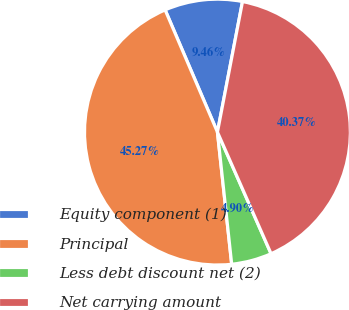Convert chart. <chart><loc_0><loc_0><loc_500><loc_500><pie_chart><fcel>Equity component (1)<fcel>Principal<fcel>Less debt discount net (2)<fcel>Net carrying amount<nl><fcel>9.46%<fcel>45.27%<fcel>4.9%<fcel>40.37%<nl></chart> 